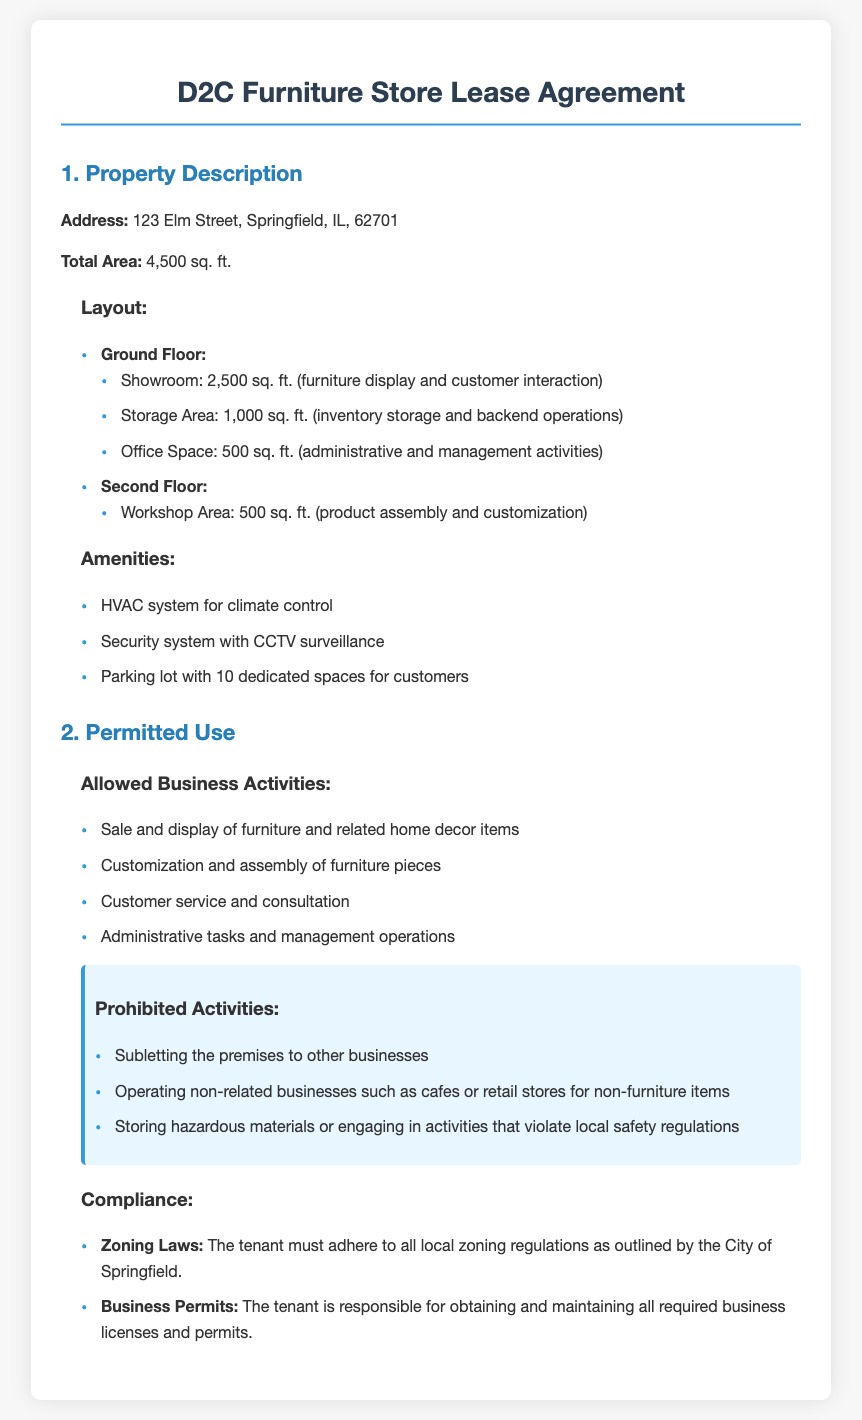What is the address of the leased property? The address is listed under the property description section of the document.
Answer: 123 Elm Street, Springfield, IL, 62701 What is the total area of the leased premises? The total area is specified in the property description section.
Answer: 4,500 sq. ft What is the size of the showroom? The showroom size is detailed in the layout section under the ground floor.
Answer: 2,500 sq. ft What activities are allowed under the permitted use? The allowed business activities are enumerated in the permitted use section.
Answer: Sale and display of furniture and related home decor items What is prohibited regarding the subletting of premises? Prohibited activities regarding subletting are mentioned under the prohibited activities subsection.
Answer: Subletting the premises to other businesses What must the tenant comply with according to zoning laws? Compliance regarding zoning laws is stated in the compliance subsection of permitted use.
Answer: Local zoning regulations How much parking space is dedicated for customers? The parking details are given in the amenities section of property description.
Answer: 10 dedicated spaces What does the workshop area size? The workshop area size is mentioned in the layout of the second floor.
Answer: 500 sq. ft What is required from the tenant regarding business permits? Required tenant responsibilities concerning business permits are listed in the compliance section.
Answer: Obtaining and maintaining all required business licenses and permits 